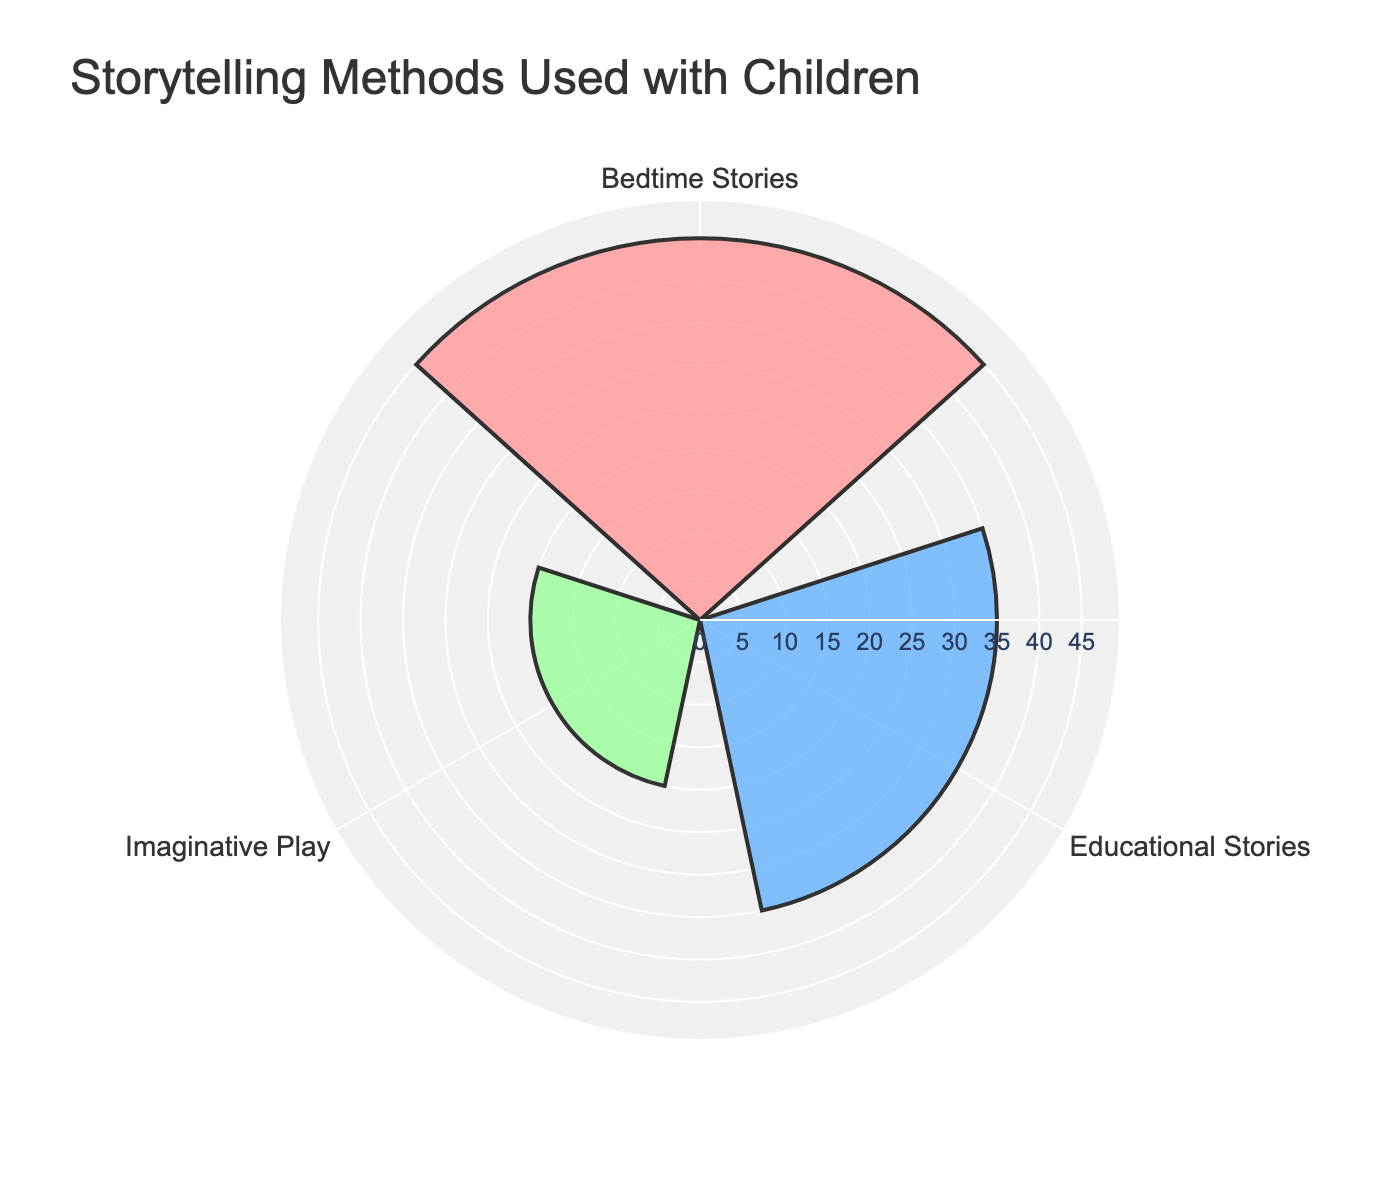What is the title of the chart? The title is located at the top of the chart and is displayed in a larger font. Just read the text directly from the visual element.
Answer: Storytelling Methods Used with Children How many storytelling methods are shown in the chart? Count the distinct labels on the chart to determine the number of groups displayed.
Answer: 3 Which storytelling method is used most frequently? Look for the bar with the greatest radius to identify the most used method.
Answer: Bedtime Stories What is the frequency of usage for Educational Stories? Locate the corresponding bar for Educational Stories and read its value.
Answer: 35 How does the frequency of Imaginative Play compare to Educational Stories? Compare the lengths of the bars for Imaginative Play and Educational Stories to see which one is longer or shorter.
Answer: Imaginative Play is less frequent than Educational Stories What is the total frequency of usage for all storytelling methods? Add up the frequencies of all bars: 45 (Bedtime Stories) + 35 (Educational Stories) + 20 (Imaginative Play).
Answer: 100 What is the difference in usage frequency between Bedtime Stories and Imaginative Play? Subtract the frequency of Imaginative Play from the frequency of Bedtime Stories: 45 - 20.
Answer: 25 Which storytelling method has the smallest frequency, and what is that value? Determine the shortest bar in the chart and read its value.
Answer: Imaginative Play, 20 In terms of the plot layout, what color represents Educational Stories? Identify the color used for Educational Stories within the chart's color scheme.
Answer: Light Blue If Bedtime Stories comprise 45% of the total storytelling methods, which method would make up 20%? Calculate the percentage each method represents based on the given data, then identify Imaginative Play based on the described proportion.
Answer: Imaginative Play 